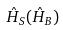<formula> <loc_0><loc_0><loc_500><loc_500>\hat { H } _ { S } ( \hat { H } _ { B } )</formula> 